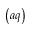Convert formula to latex. <formula><loc_0><loc_0><loc_500><loc_500>\left ( a q \right )</formula> 